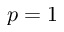<formula> <loc_0><loc_0><loc_500><loc_500>p = 1</formula> 